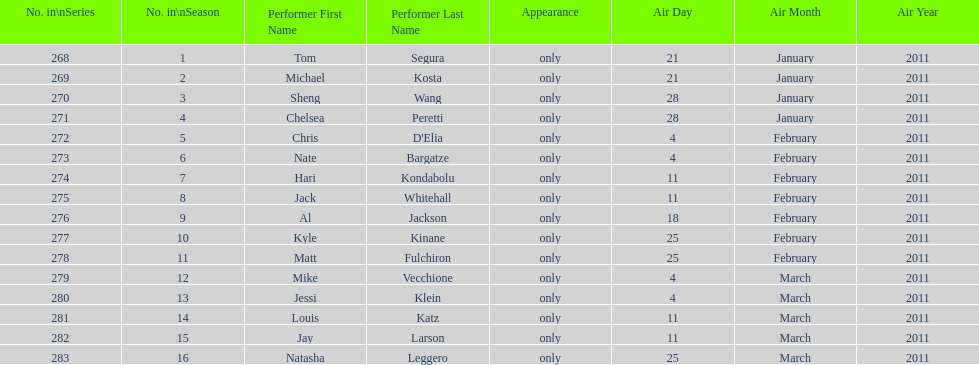Which month had the most air dates? February. 